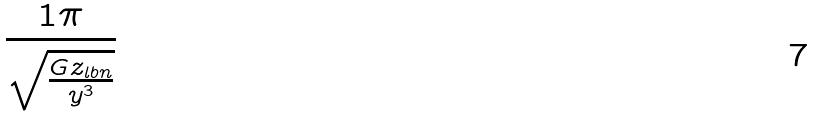<formula> <loc_0><loc_0><loc_500><loc_500>\frac { 1 \pi } { \sqrt { \frac { G z _ { l b n } } { y ^ { 3 } } } }</formula> 